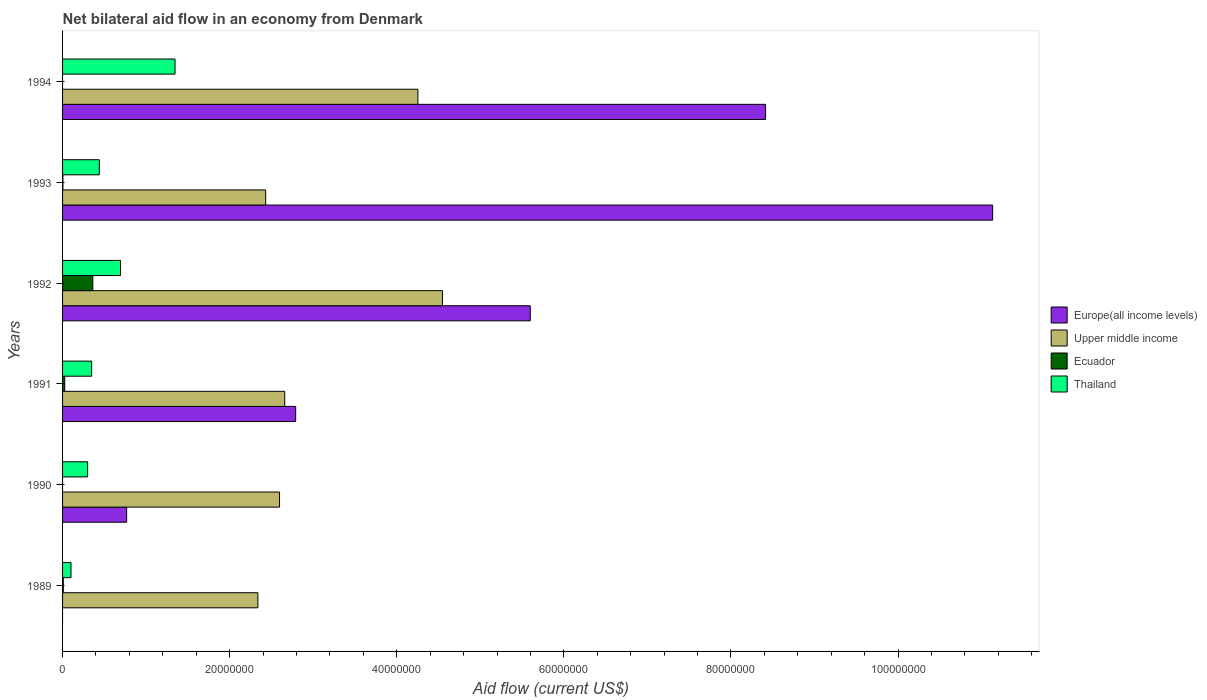How many different coloured bars are there?
Your answer should be very brief. 4. How many groups of bars are there?
Ensure brevity in your answer.  6. Are the number of bars on each tick of the Y-axis equal?
Make the answer very short. No. How many bars are there on the 4th tick from the top?
Make the answer very short. 4. How many bars are there on the 3rd tick from the bottom?
Keep it short and to the point. 4. What is the label of the 6th group of bars from the top?
Provide a short and direct response. 1989. What is the net bilateral aid flow in Upper middle income in 1994?
Give a very brief answer. 4.25e+07. Across all years, what is the maximum net bilateral aid flow in Thailand?
Keep it short and to the point. 1.35e+07. Across all years, what is the minimum net bilateral aid flow in Ecuador?
Offer a very short reply. 0. In which year was the net bilateral aid flow in Upper middle income maximum?
Offer a very short reply. 1992. What is the total net bilateral aid flow in Europe(all income levels) in the graph?
Give a very brief answer. 2.87e+08. What is the difference between the net bilateral aid flow in Europe(all income levels) in 1991 and that in 1992?
Offer a very short reply. -2.81e+07. What is the difference between the net bilateral aid flow in Upper middle income in 1990 and the net bilateral aid flow in Europe(all income levels) in 1992?
Your response must be concise. -3.00e+07. What is the average net bilateral aid flow in Europe(all income levels) per year?
Offer a very short reply. 4.78e+07. In the year 1991, what is the difference between the net bilateral aid flow in Europe(all income levels) and net bilateral aid flow in Upper middle income?
Your answer should be very brief. 1.31e+06. In how many years, is the net bilateral aid flow in Upper middle income greater than 84000000 US$?
Make the answer very short. 0. What is the ratio of the net bilateral aid flow in Europe(all income levels) in 1993 to that in 1994?
Your answer should be compact. 1.32. What is the difference between the highest and the second highest net bilateral aid flow in Thailand?
Your response must be concise. 6.52e+06. What is the difference between the highest and the lowest net bilateral aid flow in Europe(all income levels)?
Your answer should be very brief. 1.11e+08. How many years are there in the graph?
Your answer should be very brief. 6. Are the values on the major ticks of X-axis written in scientific E-notation?
Give a very brief answer. No. Does the graph contain grids?
Make the answer very short. No. How are the legend labels stacked?
Ensure brevity in your answer.  Vertical. What is the title of the graph?
Your answer should be compact. Net bilateral aid flow in an economy from Denmark. What is the label or title of the X-axis?
Offer a very short reply. Aid flow (current US$). What is the label or title of the Y-axis?
Provide a succinct answer. Years. What is the Aid flow (current US$) in Europe(all income levels) in 1989?
Keep it short and to the point. 0. What is the Aid flow (current US$) of Upper middle income in 1989?
Provide a succinct answer. 2.34e+07. What is the Aid flow (current US$) of Thailand in 1989?
Offer a terse response. 1.01e+06. What is the Aid flow (current US$) in Europe(all income levels) in 1990?
Give a very brief answer. 7.67e+06. What is the Aid flow (current US$) in Upper middle income in 1990?
Your answer should be compact. 2.60e+07. What is the Aid flow (current US$) of Thailand in 1990?
Keep it short and to the point. 3.00e+06. What is the Aid flow (current US$) in Europe(all income levels) in 1991?
Give a very brief answer. 2.79e+07. What is the Aid flow (current US$) of Upper middle income in 1991?
Offer a terse response. 2.66e+07. What is the Aid flow (current US$) in Thailand in 1991?
Make the answer very short. 3.48e+06. What is the Aid flow (current US$) of Europe(all income levels) in 1992?
Ensure brevity in your answer.  5.60e+07. What is the Aid flow (current US$) in Upper middle income in 1992?
Your answer should be very brief. 4.55e+07. What is the Aid flow (current US$) in Ecuador in 1992?
Your answer should be very brief. 3.62e+06. What is the Aid flow (current US$) in Thailand in 1992?
Make the answer very short. 6.94e+06. What is the Aid flow (current US$) of Europe(all income levels) in 1993?
Ensure brevity in your answer.  1.11e+08. What is the Aid flow (current US$) of Upper middle income in 1993?
Provide a succinct answer. 2.43e+07. What is the Aid flow (current US$) in Thailand in 1993?
Give a very brief answer. 4.40e+06. What is the Aid flow (current US$) in Europe(all income levels) in 1994?
Keep it short and to the point. 8.41e+07. What is the Aid flow (current US$) in Upper middle income in 1994?
Ensure brevity in your answer.  4.25e+07. What is the Aid flow (current US$) of Thailand in 1994?
Your answer should be compact. 1.35e+07. Across all years, what is the maximum Aid flow (current US$) of Europe(all income levels)?
Offer a very short reply. 1.11e+08. Across all years, what is the maximum Aid flow (current US$) in Upper middle income?
Offer a very short reply. 4.55e+07. Across all years, what is the maximum Aid flow (current US$) of Ecuador?
Give a very brief answer. 3.62e+06. Across all years, what is the maximum Aid flow (current US$) of Thailand?
Give a very brief answer. 1.35e+07. Across all years, what is the minimum Aid flow (current US$) of Europe(all income levels)?
Offer a terse response. 0. Across all years, what is the minimum Aid flow (current US$) in Upper middle income?
Ensure brevity in your answer.  2.34e+07. Across all years, what is the minimum Aid flow (current US$) of Thailand?
Offer a terse response. 1.01e+06. What is the total Aid flow (current US$) in Europe(all income levels) in the graph?
Your answer should be compact. 2.87e+08. What is the total Aid flow (current US$) of Upper middle income in the graph?
Your response must be concise. 1.88e+08. What is the total Aid flow (current US$) of Ecuador in the graph?
Offer a very short reply. 4.01e+06. What is the total Aid flow (current US$) in Thailand in the graph?
Make the answer very short. 3.23e+07. What is the difference between the Aid flow (current US$) in Upper middle income in 1989 and that in 1990?
Provide a succinct answer. -2.59e+06. What is the difference between the Aid flow (current US$) in Thailand in 1989 and that in 1990?
Keep it short and to the point. -1.99e+06. What is the difference between the Aid flow (current US$) of Upper middle income in 1989 and that in 1991?
Provide a succinct answer. -3.21e+06. What is the difference between the Aid flow (current US$) of Ecuador in 1989 and that in 1991?
Provide a succinct answer. -1.70e+05. What is the difference between the Aid flow (current US$) in Thailand in 1989 and that in 1991?
Provide a succinct answer. -2.47e+06. What is the difference between the Aid flow (current US$) in Upper middle income in 1989 and that in 1992?
Provide a short and direct response. -2.21e+07. What is the difference between the Aid flow (current US$) of Ecuador in 1989 and that in 1992?
Your answer should be compact. -3.53e+06. What is the difference between the Aid flow (current US$) of Thailand in 1989 and that in 1992?
Your answer should be very brief. -5.93e+06. What is the difference between the Aid flow (current US$) in Upper middle income in 1989 and that in 1993?
Provide a short and direct response. -9.30e+05. What is the difference between the Aid flow (current US$) in Ecuador in 1989 and that in 1993?
Keep it short and to the point. 5.00e+04. What is the difference between the Aid flow (current US$) of Thailand in 1989 and that in 1993?
Your answer should be compact. -3.39e+06. What is the difference between the Aid flow (current US$) of Upper middle income in 1989 and that in 1994?
Your response must be concise. -1.92e+07. What is the difference between the Aid flow (current US$) of Thailand in 1989 and that in 1994?
Provide a succinct answer. -1.24e+07. What is the difference between the Aid flow (current US$) in Europe(all income levels) in 1990 and that in 1991?
Give a very brief answer. -2.02e+07. What is the difference between the Aid flow (current US$) of Upper middle income in 1990 and that in 1991?
Make the answer very short. -6.20e+05. What is the difference between the Aid flow (current US$) of Thailand in 1990 and that in 1991?
Your answer should be compact. -4.80e+05. What is the difference between the Aid flow (current US$) of Europe(all income levels) in 1990 and that in 1992?
Provide a succinct answer. -4.83e+07. What is the difference between the Aid flow (current US$) in Upper middle income in 1990 and that in 1992?
Give a very brief answer. -1.95e+07. What is the difference between the Aid flow (current US$) in Thailand in 1990 and that in 1992?
Make the answer very short. -3.94e+06. What is the difference between the Aid flow (current US$) in Europe(all income levels) in 1990 and that in 1993?
Give a very brief answer. -1.04e+08. What is the difference between the Aid flow (current US$) in Upper middle income in 1990 and that in 1993?
Offer a terse response. 1.66e+06. What is the difference between the Aid flow (current US$) of Thailand in 1990 and that in 1993?
Ensure brevity in your answer.  -1.40e+06. What is the difference between the Aid flow (current US$) in Europe(all income levels) in 1990 and that in 1994?
Offer a very short reply. -7.65e+07. What is the difference between the Aid flow (current US$) in Upper middle income in 1990 and that in 1994?
Offer a terse response. -1.66e+07. What is the difference between the Aid flow (current US$) of Thailand in 1990 and that in 1994?
Offer a terse response. -1.05e+07. What is the difference between the Aid flow (current US$) of Europe(all income levels) in 1991 and that in 1992?
Your answer should be compact. -2.81e+07. What is the difference between the Aid flow (current US$) of Upper middle income in 1991 and that in 1992?
Your response must be concise. -1.89e+07. What is the difference between the Aid flow (current US$) of Ecuador in 1991 and that in 1992?
Provide a short and direct response. -3.36e+06. What is the difference between the Aid flow (current US$) in Thailand in 1991 and that in 1992?
Keep it short and to the point. -3.46e+06. What is the difference between the Aid flow (current US$) in Europe(all income levels) in 1991 and that in 1993?
Your answer should be compact. -8.34e+07. What is the difference between the Aid flow (current US$) in Upper middle income in 1991 and that in 1993?
Keep it short and to the point. 2.28e+06. What is the difference between the Aid flow (current US$) of Ecuador in 1991 and that in 1993?
Offer a terse response. 2.20e+05. What is the difference between the Aid flow (current US$) in Thailand in 1991 and that in 1993?
Your response must be concise. -9.20e+05. What is the difference between the Aid flow (current US$) in Europe(all income levels) in 1991 and that in 1994?
Your answer should be compact. -5.62e+07. What is the difference between the Aid flow (current US$) in Upper middle income in 1991 and that in 1994?
Your answer should be compact. -1.59e+07. What is the difference between the Aid flow (current US$) of Thailand in 1991 and that in 1994?
Provide a short and direct response. -9.98e+06. What is the difference between the Aid flow (current US$) of Europe(all income levels) in 1992 and that in 1993?
Keep it short and to the point. -5.53e+07. What is the difference between the Aid flow (current US$) of Upper middle income in 1992 and that in 1993?
Ensure brevity in your answer.  2.12e+07. What is the difference between the Aid flow (current US$) of Ecuador in 1992 and that in 1993?
Ensure brevity in your answer.  3.58e+06. What is the difference between the Aid flow (current US$) in Thailand in 1992 and that in 1993?
Your response must be concise. 2.54e+06. What is the difference between the Aid flow (current US$) of Europe(all income levels) in 1992 and that in 1994?
Give a very brief answer. -2.82e+07. What is the difference between the Aid flow (current US$) in Upper middle income in 1992 and that in 1994?
Keep it short and to the point. 2.94e+06. What is the difference between the Aid flow (current US$) of Thailand in 1992 and that in 1994?
Give a very brief answer. -6.52e+06. What is the difference between the Aid flow (current US$) of Europe(all income levels) in 1993 and that in 1994?
Give a very brief answer. 2.72e+07. What is the difference between the Aid flow (current US$) in Upper middle income in 1993 and that in 1994?
Keep it short and to the point. -1.82e+07. What is the difference between the Aid flow (current US$) of Thailand in 1993 and that in 1994?
Give a very brief answer. -9.06e+06. What is the difference between the Aid flow (current US$) in Upper middle income in 1989 and the Aid flow (current US$) in Thailand in 1990?
Offer a terse response. 2.04e+07. What is the difference between the Aid flow (current US$) in Ecuador in 1989 and the Aid flow (current US$) in Thailand in 1990?
Offer a very short reply. -2.91e+06. What is the difference between the Aid flow (current US$) of Upper middle income in 1989 and the Aid flow (current US$) of Ecuador in 1991?
Ensure brevity in your answer.  2.31e+07. What is the difference between the Aid flow (current US$) in Upper middle income in 1989 and the Aid flow (current US$) in Thailand in 1991?
Keep it short and to the point. 1.99e+07. What is the difference between the Aid flow (current US$) of Ecuador in 1989 and the Aid flow (current US$) of Thailand in 1991?
Offer a terse response. -3.39e+06. What is the difference between the Aid flow (current US$) of Upper middle income in 1989 and the Aid flow (current US$) of Ecuador in 1992?
Provide a succinct answer. 1.98e+07. What is the difference between the Aid flow (current US$) in Upper middle income in 1989 and the Aid flow (current US$) in Thailand in 1992?
Provide a short and direct response. 1.64e+07. What is the difference between the Aid flow (current US$) in Ecuador in 1989 and the Aid flow (current US$) in Thailand in 1992?
Keep it short and to the point. -6.85e+06. What is the difference between the Aid flow (current US$) of Upper middle income in 1989 and the Aid flow (current US$) of Ecuador in 1993?
Your answer should be very brief. 2.33e+07. What is the difference between the Aid flow (current US$) of Upper middle income in 1989 and the Aid flow (current US$) of Thailand in 1993?
Your response must be concise. 1.90e+07. What is the difference between the Aid flow (current US$) in Ecuador in 1989 and the Aid flow (current US$) in Thailand in 1993?
Ensure brevity in your answer.  -4.31e+06. What is the difference between the Aid flow (current US$) in Upper middle income in 1989 and the Aid flow (current US$) in Thailand in 1994?
Keep it short and to the point. 9.92e+06. What is the difference between the Aid flow (current US$) of Ecuador in 1989 and the Aid flow (current US$) of Thailand in 1994?
Ensure brevity in your answer.  -1.34e+07. What is the difference between the Aid flow (current US$) of Europe(all income levels) in 1990 and the Aid flow (current US$) of Upper middle income in 1991?
Keep it short and to the point. -1.89e+07. What is the difference between the Aid flow (current US$) in Europe(all income levels) in 1990 and the Aid flow (current US$) in Ecuador in 1991?
Provide a short and direct response. 7.41e+06. What is the difference between the Aid flow (current US$) of Europe(all income levels) in 1990 and the Aid flow (current US$) of Thailand in 1991?
Your response must be concise. 4.19e+06. What is the difference between the Aid flow (current US$) in Upper middle income in 1990 and the Aid flow (current US$) in Ecuador in 1991?
Make the answer very short. 2.57e+07. What is the difference between the Aid flow (current US$) in Upper middle income in 1990 and the Aid flow (current US$) in Thailand in 1991?
Provide a short and direct response. 2.25e+07. What is the difference between the Aid flow (current US$) in Europe(all income levels) in 1990 and the Aid flow (current US$) in Upper middle income in 1992?
Provide a succinct answer. -3.78e+07. What is the difference between the Aid flow (current US$) in Europe(all income levels) in 1990 and the Aid flow (current US$) in Ecuador in 1992?
Keep it short and to the point. 4.05e+06. What is the difference between the Aid flow (current US$) of Europe(all income levels) in 1990 and the Aid flow (current US$) of Thailand in 1992?
Make the answer very short. 7.30e+05. What is the difference between the Aid flow (current US$) in Upper middle income in 1990 and the Aid flow (current US$) in Ecuador in 1992?
Provide a short and direct response. 2.24e+07. What is the difference between the Aid flow (current US$) of Upper middle income in 1990 and the Aid flow (current US$) of Thailand in 1992?
Ensure brevity in your answer.  1.90e+07. What is the difference between the Aid flow (current US$) in Europe(all income levels) in 1990 and the Aid flow (current US$) in Upper middle income in 1993?
Ensure brevity in your answer.  -1.66e+07. What is the difference between the Aid flow (current US$) of Europe(all income levels) in 1990 and the Aid flow (current US$) of Ecuador in 1993?
Offer a very short reply. 7.63e+06. What is the difference between the Aid flow (current US$) in Europe(all income levels) in 1990 and the Aid flow (current US$) in Thailand in 1993?
Your answer should be compact. 3.27e+06. What is the difference between the Aid flow (current US$) of Upper middle income in 1990 and the Aid flow (current US$) of Ecuador in 1993?
Offer a terse response. 2.59e+07. What is the difference between the Aid flow (current US$) in Upper middle income in 1990 and the Aid flow (current US$) in Thailand in 1993?
Your answer should be compact. 2.16e+07. What is the difference between the Aid flow (current US$) of Europe(all income levels) in 1990 and the Aid flow (current US$) of Upper middle income in 1994?
Ensure brevity in your answer.  -3.49e+07. What is the difference between the Aid flow (current US$) in Europe(all income levels) in 1990 and the Aid flow (current US$) in Thailand in 1994?
Make the answer very short. -5.79e+06. What is the difference between the Aid flow (current US$) in Upper middle income in 1990 and the Aid flow (current US$) in Thailand in 1994?
Offer a very short reply. 1.25e+07. What is the difference between the Aid flow (current US$) of Europe(all income levels) in 1991 and the Aid flow (current US$) of Upper middle income in 1992?
Your response must be concise. -1.76e+07. What is the difference between the Aid flow (current US$) of Europe(all income levels) in 1991 and the Aid flow (current US$) of Ecuador in 1992?
Your response must be concise. 2.43e+07. What is the difference between the Aid flow (current US$) in Europe(all income levels) in 1991 and the Aid flow (current US$) in Thailand in 1992?
Offer a very short reply. 2.10e+07. What is the difference between the Aid flow (current US$) of Upper middle income in 1991 and the Aid flow (current US$) of Ecuador in 1992?
Offer a terse response. 2.30e+07. What is the difference between the Aid flow (current US$) of Upper middle income in 1991 and the Aid flow (current US$) of Thailand in 1992?
Make the answer very short. 1.96e+07. What is the difference between the Aid flow (current US$) of Ecuador in 1991 and the Aid flow (current US$) of Thailand in 1992?
Your response must be concise. -6.68e+06. What is the difference between the Aid flow (current US$) in Europe(all income levels) in 1991 and the Aid flow (current US$) in Upper middle income in 1993?
Ensure brevity in your answer.  3.59e+06. What is the difference between the Aid flow (current US$) in Europe(all income levels) in 1991 and the Aid flow (current US$) in Ecuador in 1993?
Offer a terse response. 2.79e+07. What is the difference between the Aid flow (current US$) of Europe(all income levels) in 1991 and the Aid flow (current US$) of Thailand in 1993?
Provide a short and direct response. 2.35e+07. What is the difference between the Aid flow (current US$) in Upper middle income in 1991 and the Aid flow (current US$) in Ecuador in 1993?
Your response must be concise. 2.66e+07. What is the difference between the Aid flow (current US$) in Upper middle income in 1991 and the Aid flow (current US$) in Thailand in 1993?
Ensure brevity in your answer.  2.22e+07. What is the difference between the Aid flow (current US$) of Ecuador in 1991 and the Aid flow (current US$) of Thailand in 1993?
Your answer should be compact. -4.14e+06. What is the difference between the Aid flow (current US$) of Europe(all income levels) in 1991 and the Aid flow (current US$) of Upper middle income in 1994?
Your response must be concise. -1.46e+07. What is the difference between the Aid flow (current US$) in Europe(all income levels) in 1991 and the Aid flow (current US$) in Thailand in 1994?
Keep it short and to the point. 1.44e+07. What is the difference between the Aid flow (current US$) of Upper middle income in 1991 and the Aid flow (current US$) of Thailand in 1994?
Your answer should be compact. 1.31e+07. What is the difference between the Aid flow (current US$) of Ecuador in 1991 and the Aid flow (current US$) of Thailand in 1994?
Give a very brief answer. -1.32e+07. What is the difference between the Aid flow (current US$) in Europe(all income levels) in 1992 and the Aid flow (current US$) in Upper middle income in 1993?
Your answer should be compact. 3.17e+07. What is the difference between the Aid flow (current US$) in Europe(all income levels) in 1992 and the Aid flow (current US$) in Ecuador in 1993?
Ensure brevity in your answer.  5.59e+07. What is the difference between the Aid flow (current US$) of Europe(all income levels) in 1992 and the Aid flow (current US$) of Thailand in 1993?
Ensure brevity in your answer.  5.16e+07. What is the difference between the Aid flow (current US$) of Upper middle income in 1992 and the Aid flow (current US$) of Ecuador in 1993?
Offer a very short reply. 4.54e+07. What is the difference between the Aid flow (current US$) of Upper middle income in 1992 and the Aid flow (current US$) of Thailand in 1993?
Ensure brevity in your answer.  4.11e+07. What is the difference between the Aid flow (current US$) of Ecuador in 1992 and the Aid flow (current US$) of Thailand in 1993?
Give a very brief answer. -7.80e+05. What is the difference between the Aid flow (current US$) of Europe(all income levels) in 1992 and the Aid flow (current US$) of Upper middle income in 1994?
Give a very brief answer. 1.34e+07. What is the difference between the Aid flow (current US$) of Europe(all income levels) in 1992 and the Aid flow (current US$) of Thailand in 1994?
Provide a succinct answer. 4.25e+07. What is the difference between the Aid flow (current US$) of Upper middle income in 1992 and the Aid flow (current US$) of Thailand in 1994?
Make the answer very short. 3.20e+07. What is the difference between the Aid flow (current US$) in Ecuador in 1992 and the Aid flow (current US$) in Thailand in 1994?
Your answer should be compact. -9.84e+06. What is the difference between the Aid flow (current US$) of Europe(all income levels) in 1993 and the Aid flow (current US$) of Upper middle income in 1994?
Make the answer very short. 6.88e+07. What is the difference between the Aid flow (current US$) of Europe(all income levels) in 1993 and the Aid flow (current US$) of Thailand in 1994?
Your response must be concise. 9.79e+07. What is the difference between the Aid flow (current US$) of Upper middle income in 1993 and the Aid flow (current US$) of Thailand in 1994?
Provide a succinct answer. 1.08e+07. What is the difference between the Aid flow (current US$) in Ecuador in 1993 and the Aid flow (current US$) in Thailand in 1994?
Your answer should be very brief. -1.34e+07. What is the average Aid flow (current US$) in Europe(all income levels) per year?
Provide a short and direct response. 4.78e+07. What is the average Aid flow (current US$) in Upper middle income per year?
Your answer should be compact. 3.14e+07. What is the average Aid flow (current US$) of Ecuador per year?
Ensure brevity in your answer.  6.68e+05. What is the average Aid flow (current US$) of Thailand per year?
Provide a short and direct response. 5.38e+06. In the year 1989, what is the difference between the Aid flow (current US$) in Upper middle income and Aid flow (current US$) in Ecuador?
Your answer should be compact. 2.33e+07. In the year 1989, what is the difference between the Aid flow (current US$) in Upper middle income and Aid flow (current US$) in Thailand?
Your answer should be very brief. 2.24e+07. In the year 1989, what is the difference between the Aid flow (current US$) in Ecuador and Aid flow (current US$) in Thailand?
Provide a short and direct response. -9.20e+05. In the year 1990, what is the difference between the Aid flow (current US$) in Europe(all income levels) and Aid flow (current US$) in Upper middle income?
Your answer should be compact. -1.83e+07. In the year 1990, what is the difference between the Aid flow (current US$) in Europe(all income levels) and Aid flow (current US$) in Thailand?
Make the answer very short. 4.67e+06. In the year 1990, what is the difference between the Aid flow (current US$) of Upper middle income and Aid flow (current US$) of Thailand?
Make the answer very short. 2.30e+07. In the year 1991, what is the difference between the Aid flow (current US$) in Europe(all income levels) and Aid flow (current US$) in Upper middle income?
Give a very brief answer. 1.31e+06. In the year 1991, what is the difference between the Aid flow (current US$) in Europe(all income levels) and Aid flow (current US$) in Ecuador?
Give a very brief answer. 2.76e+07. In the year 1991, what is the difference between the Aid flow (current US$) in Europe(all income levels) and Aid flow (current US$) in Thailand?
Provide a short and direct response. 2.44e+07. In the year 1991, what is the difference between the Aid flow (current US$) in Upper middle income and Aid flow (current US$) in Ecuador?
Give a very brief answer. 2.63e+07. In the year 1991, what is the difference between the Aid flow (current US$) in Upper middle income and Aid flow (current US$) in Thailand?
Your answer should be compact. 2.31e+07. In the year 1991, what is the difference between the Aid flow (current US$) of Ecuador and Aid flow (current US$) of Thailand?
Your answer should be compact. -3.22e+06. In the year 1992, what is the difference between the Aid flow (current US$) of Europe(all income levels) and Aid flow (current US$) of Upper middle income?
Make the answer very short. 1.05e+07. In the year 1992, what is the difference between the Aid flow (current US$) in Europe(all income levels) and Aid flow (current US$) in Ecuador?
Provide a succinct answer. 5.24e+07. In the year 1992, what is the difference between the Aid flow (current US$) of Europe(all income levels) and Aid flow (current US$) of Thailand?
Your response must be concise. 4.90e+07. In the year 1992, what is the difference between the Aid flow (current US$) in Upper middle income and Aid flow (current US$) in Ecuador?
Offer a very short reply. 4.18e+07. In the year 1992, what is the difference between the Aid flow (current US$) in Upper middle income and Aid flow (current US$) in Thailand?
Give a very brief answer. 3.85e+07. In the year 1992, what is the difference between the Aid flow (current US$) of Ecuador and Aid flow (current US$) of Thailand?
Keep it short and to the point. -3.32e+06. In the year 1993, what is the difference between the Aid flow (current US$) in Europe(all income levels) and Aid flow (current US$) in Upper middle income?
Provide a short and direct response. 8.70e+07. In the year 1993, what is the difference between the Aid flow (current US$) in Europe(all income levels) and Aid flow (current US$) in Ecuador?
Make the answer very short. 1.11e+08. In the year 1993, what is the difference between the Aid flow (current US$) in Europe(all income levels) and Aid flow (current US$) in Thailand?
Keep it short and to the point. 1.07e+08. In the year 1993, what is the difference between the Aid flow (current US$) of Upper middle income and Aid flow (current US$) of Ecuador?
Keep it short and to the point. 2.43e+07. In the year 1993, what is the difference between the Aid flow (current US$) in Upper middle income and Aid flow (current US$) in Thailand?
Keep it short and to the point. 1.99e+07. In the year 1993, what is the difference between the Aid flow (current US$) of Ecuador and Aid flow (current US$) of Thailand?
Offer a very short reply. -4.36e+06. In the year 1994, what is the difference between the Aid flow (current US$) in Europe(all income levels) and Aid flow (current US$) in Upper middle income?
Offer a very short reply. 4.16e+07. In the year 1994, what is the difference between the Aid flow (current US$) in Europe(all income levels) and Aid flow (current US$) in Thailand?
Keep it short and to the point. 7.07e+07. In the year 1994, what is the difference between the Aid flow (current US$) of Upper middle income and Aid flow (current US$) of Thailand?
Provide a succinct answer. 2.91e+07. What is the ratio of the Aid flow (current US$) of Upper middle income in 1989 to that in 1990?
Offer a very short reply. 0.9. What is the ratio of the Aid flow (current US$) in Thailand in 1989 to that in 1990?
Offer a very short reply. 0.34. What is the ratio of the Aid flow (current US$) in Upper middle income in 1989 to that in 1991?
Offer a terse response. 0.88. What is the ratio of the Aid flow (current US$) in Ecuador in 1989 to that in 1991?
Ensure brevity in your answer.  0.35. What is the ratio of the Aid flow (current US$) of Thailand in 1989 to that in 1991?
Provide a succinct answer. 0.29. What is the ratio of the Aid flow (current US$) in Upper middle income in 1989 to that in 1992?
Offer a very short reply. 0.51. What is the ratio of the Aid flow (current US$) of Ecuador in 1989 to that in 1992?
Offer a very short reply. 0.02. What is the ratio of the Aid flow (current US$) of Thailand in 1989 to that in 1992?
Provide a short and direct response. 0.15. What is the ratio of the Aid flow (current US$) in Upper middle income in 1989 to that in 1993?
Your answer should be very brief. 0.96. What is the ratio of the Aid flow (current US$) of Ecuador in 1989 to that in 1993?
Give a very brief answer. 2.25. What is the ratio of the Aid flow (current US$) of Thailand in 1989 to that in 1993?
Your response must be concise. 0.23. What is the ratio of the Aid flow (current US$) in Upper middle income in 1989 to that in 1994?
Make the answer very short. 0.55. What is the ratio of the Aid flow (current US$) in Thailand in 1989 to that in 1994?
Give a very brief answer. 0.07. What is the ratio of the Aid flow (current US$) of Europe(all income levels) in 1990 to that in 1991?
Offer a terse response. 0.27. What is the ratio of the Aid flow (current US$) in Upper middle income in 1990 to that in 1991?
Your answer should be compact. 0.98. What is the ratio of the Aid flow (current US$) of Thailand in 1990 to that in 1991?
Ensure brevity in your answer.  0.86. What is the ratio of the Aid flow (current US$) in Europe(all income levels) in 1990 to that in 1992?
Offer a very short reply. 0.14. What is the ratio of the Aid flow (current US$) in Upper middle income in 1990 to that in 1992?
Your answer should be compact. 0.57. What is the ratio of the Aid flow (current US$) of Thailand in 1990 to that in 1992?
Make the answer very short. 0.43. What is the ratio of the Aid flow (current US$) of Europe(all income levels) in 1990 to that in 1993?
Ensure brevity in your answer.  0.07. What is the ratio of the Aid flow (current US$) of Upper middle income in 1990 to that in 1993?
Provide a succinct answer. 1.07. What is the ratio of the Aid flow (current US$) in Thailand in 1990 to that in 1993?
Make the answer very short. 0.68. What is the ratio of the Aid flow (current US$) in Europe(all income levels) in 1990 to that in 1994?
Provide a short and direct response. 0.09. What is the ratio of the Aid flow (current US$) of Upper middle income in 1990 to that in 1994?
Your answer should be very brief. 0.61. What is the ratio of the Aid flow (current US$) in Thailand in 1990 to that in 1994?
Offer a terse response. 0.22. What is the ratio of the Aid flow (current US$) of Europe(all income levels) in 1991 to that in 1992?
Your response must be concise. 0.5. What is the ratio of the Aid flow (current US$) of Upper middle income in 1991 to that in 1992?
Your answer should be very brief. 0.58. What is the ratio of the Aid flow (current US$) of Ecuador in 1991 to that in 1992?
Provide a succinct answer. 0.07. What is the ratio of the Aid flow (current US$) of Thailand in 1991 to that in 1992?
Keep it short and to the point. 0.5. What is the ratio of the Aid flow (current US$) in Europe(all income levels) in 1991 to that in 1993?
Give a very brief answer. 0.25. What is the ratio of the Aid flow (current US$) in Upper middle income in 1991 to that in 1993?
Keep it short and to the point. 1.09. What is the ratio of the Aid flow (current US$) in Ecuador in 1991 to that in 1993?
Keep it short and to the point. 6.5. What is the ratio of the Aid flow (current US$) in Thailand in 1991 to that in 1993?
Ensure brevity in your answer.  0.79. What is the ratio of the Aid flow (current US$) of Europe(all income levels) in 1991 to that in 1994?
Provide a succinct answer. 0.33. What is the ratio of the Aid flow (current US$) in Upper middle income in 1991 to that in 1994?
Provide a short and direct response. 0.63. What is the ratio of the Aid flow (current US$) of Thailand in 1991 to that in 1994?
Offer a terse response. 0.26. What is the ratio of the Aid flow (current US$) in Europe(all income levels) in 1992 to that in 1993?
Your response must be concise. 0.5. What is the ratio of the Aid flow (current US$) of Upper middle income in 1992 to that in 1993?
Your response must be concise. 1.87. What is the ratio of the Aid flow (current US$) of Ecuador in 1992 to that in 1993?
Give a very brief answer. 90.5. What is the ratio of the Aid flow (current US$) of Thailand in 1992 to that in 1993?
Offer a terse response. 1.58. What is the ratio of the Aid flow (current US$) of Europe(all income levels) in 1992 to that in 1994?
Provide a succinct answer. 0.67. What is the ratio of the Aid flow (current US$) of Upper middle income in 1992 to that in 1994?
Offer a very short reply. 1.07. What is the ratio of the Aid flow (current US$) of Thailand in 1992 to that in 1994?
Your response must be concise. 0.52. What is the ratio of the Aid flow (current US$) in Europe(all income levels) in 1993 to that in 1994?
Keep it short and to the point. 1.32. What is the ratio of the Aid flow (current US$) of Upper middle income in 1993 to that in 1994?
Your response must be concise. 0.57. What is the ratio of the Aid flow (current US$) of Thailand in 1993 to that in 1994?
Give a very brief answer. 0.33. What is the difference between the highest and the second highest Aid flow (current US$) in Europe(all income levels)?
Your answer should be compact. 2.72e+07. What is the difference between the highest and the second highest Aid flow (current US$) in Upper middle income?
Give a very brief answer. 2.94e+06. What is the difference between the highest and the second highest Aid flow (current US$) of Ecuador?
Offer a very short reply. 3.36e+06. What is the difference between the highest and the second highest Aid flow (current US$) in Thailand?
Offer a terse response. 6.52e+06. What is the difference between the highest and the lowest Aid flow (current US$) in Europe(all income levels)?
Provide a succinct answer. 1.11e+08. What is the difference between the highest and the lowest Aid flow (current US$) of Upper middle income?
Make the answer very short. 2.21e+07. What is the difference between the highest and the lowest Aid flow (current US$) of Ecuador?
Give a very brief answer. 3.62e+06. What is the difference between the highest and the lowest Aid flow (current US$) in Thailand?
Ensure brevity in your answer.  1.24e+07. 